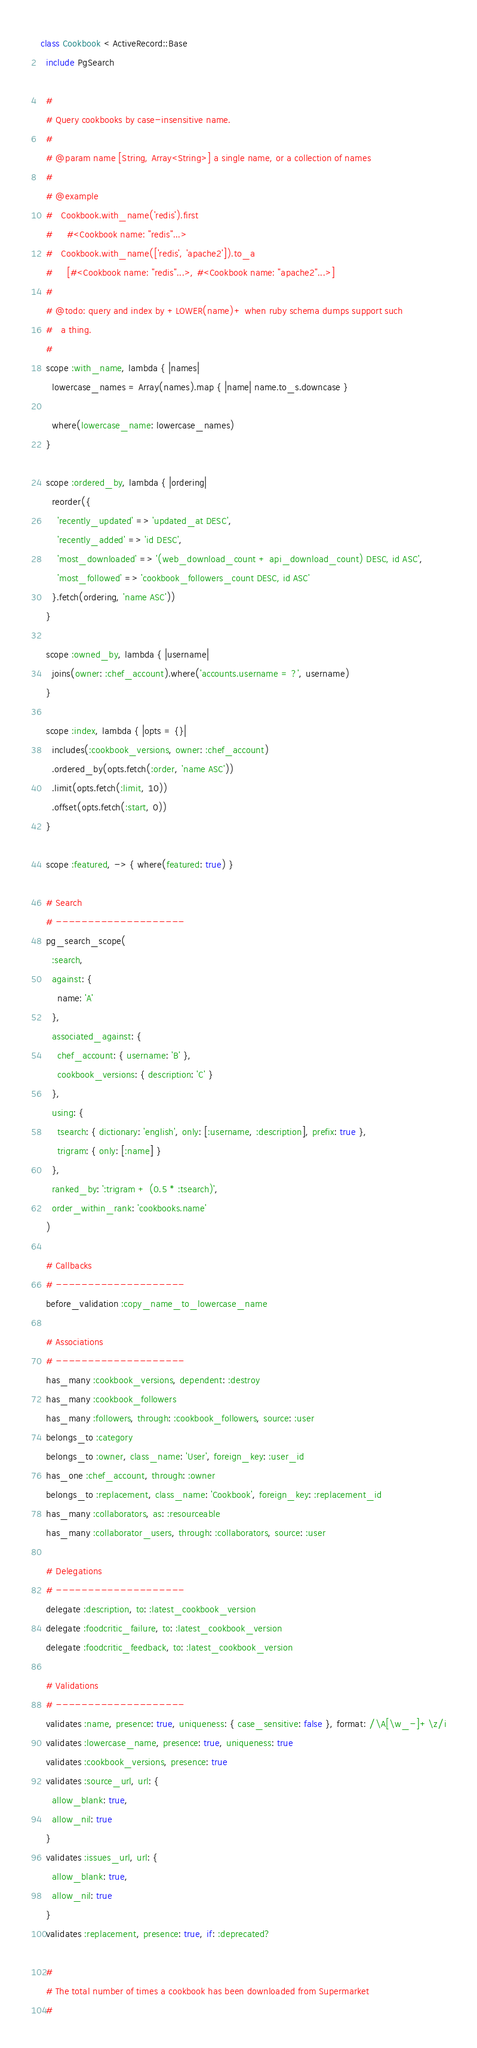Convert code to text. <code><loc_0><loc_0><loc_500><loc_500><_Ruby_>class Cookbook < ActiveRecord::Base
  include PgSearch

  #
  # Query cookbooks by case-insensitive name.
  #
  # @param name [String, Array<String>] a single name, or a collection of names
  #
  # @example
  #   Cookbook.with_name('redis').first
  #     #<Cookbook name: "redis"...>
  #   Cookbook.with_name(['redis', 'apache2']).to_a
  #     [#<Cookbook name: "redis"...>, #<Cookbook name: "apache2"...>]
  #
  # @todo: query and index by +LOWER(name)+ when ruby schema dumps support such
  #   a thing.
  #
  scope :with_name, lambda { |names|
    lowercase_names = Array(names).map { |name| name.to_s.downcase }

    where(lowercase_name: lowercase_names)
  }

  scope :ordered_by, lambda { |ordering|
    reorder({
      'recently_updated' => 'updated_at DESC',
      'recently_added' => 'id DESC',
      'most_downloaded' => '(web_download_count + api_download_count) DESC, id ASC',
      'most_followed' => 'cookbook_followers_count DESC, id ASC'
    }.fetch(ordering, 'name ASC'))
  }

  scope :owned_by, lambda { |username|
    joins(owner: :chef_account).where('accounts.username = ?', username)
  }

  scope :index, lambda { |opts = {}|
    includes(:cookbook_versions, owner: :chef_account)
    .ordered_by(opts.fetch(:order, 'name ASC'))
    .limit(opts.fetch(:limit, 10))
    .offset(opts.fetch(:start, 0))
  }

  scope :featured, -> { where(featured: true) }

  # Search
  # --------------------
  pg_search_scope(
    :search,
    against: {
      name: 'A'
    },
    associated_against: {
      chef_account: { username: 'B' },
      cookbook_versions: { description: 'C' }
    },
    using: {
      tsearch: { dictionary: 'english', only: [:username, :description], prefix: true },
      trigram: { only: [:name] }
    },
    ranked_by: ':trigram + (0.5 * :tsearch)',
    order_within_rank: 'cookbooks.name'
  )

  # Callbacks
  # --------------------
  before_validation :copy_name_to_lowercase_name

  # Associations
  # --------------------
  has_many :cookbook_versions, dependent: :destroy
  has_many :cookbook_followers
  has_many :followers, through: :cookbook_followers, source: :user
  belongs_to :category
  belongs_to :owner, class_name: 'User', foreign_key: :user_id
  has_one :chef_account, through: :owner
  belongs_to :replacement, class_name: 'Cookbook', foreign_key: :replacement_id
  has_many :collaborators, as: :resourceable
  has_many :collaborator_users, through: :collaborators, source: :user

  # Delegations
  # --------------------
  delegate :description, to: :latest_cookbook_version
  delegate :foodcritic_failure, to: :latest_cookbook_version
  delegate :foodcritic_feedback, to: :latest_cookbook_version

  # Validations
  # --------------------
  validates :name, presence: true, uniqueness: { case_sensitive: false }, format: /\A[\w_-]+\z/i
  validates :lowercase_name, presence: true, uniqueness: true
  validates :cookbook_versions, presence: true
  validates :source_url, url: {
    allow_blank: true,
    allow_nil: true
  }
  validates :issues_url, url: {
    allow_blank: true,
    allow_nil: true
  }
  validates :replacement, presence: true, if: :deprecated?

  #
  # The total number of times a cookbook has been downloaded from Supermarket
  #</code> 